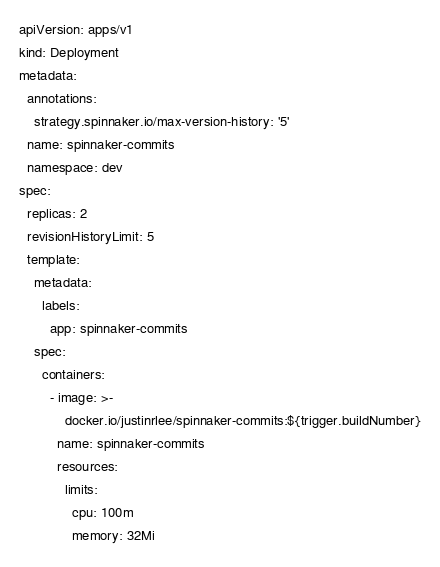<code> <loc_0><loc_0><loc_500><loc_500><_YAML_>apiVersion: apps/v1
kind: Deployment
metadata:
  annotations:
    strategy.spinnaker.io/max-version-history: '5'
  name: spinnaker-commits
  namespace: dev
spec:
  replicas: 2 
  revisionHistoryLimit: 5
  template:
    metadata:
      labels:
        app: spinnaker-commits
    spec:
      containers:
        - image: >-
            docker.io/justinrlee/spinnaker-commits:${trigger.buildNumber}
          name: spinnaker-commits
          resources:
            limits:
              cpu: 100m
              memory: 32Mi
</code> 